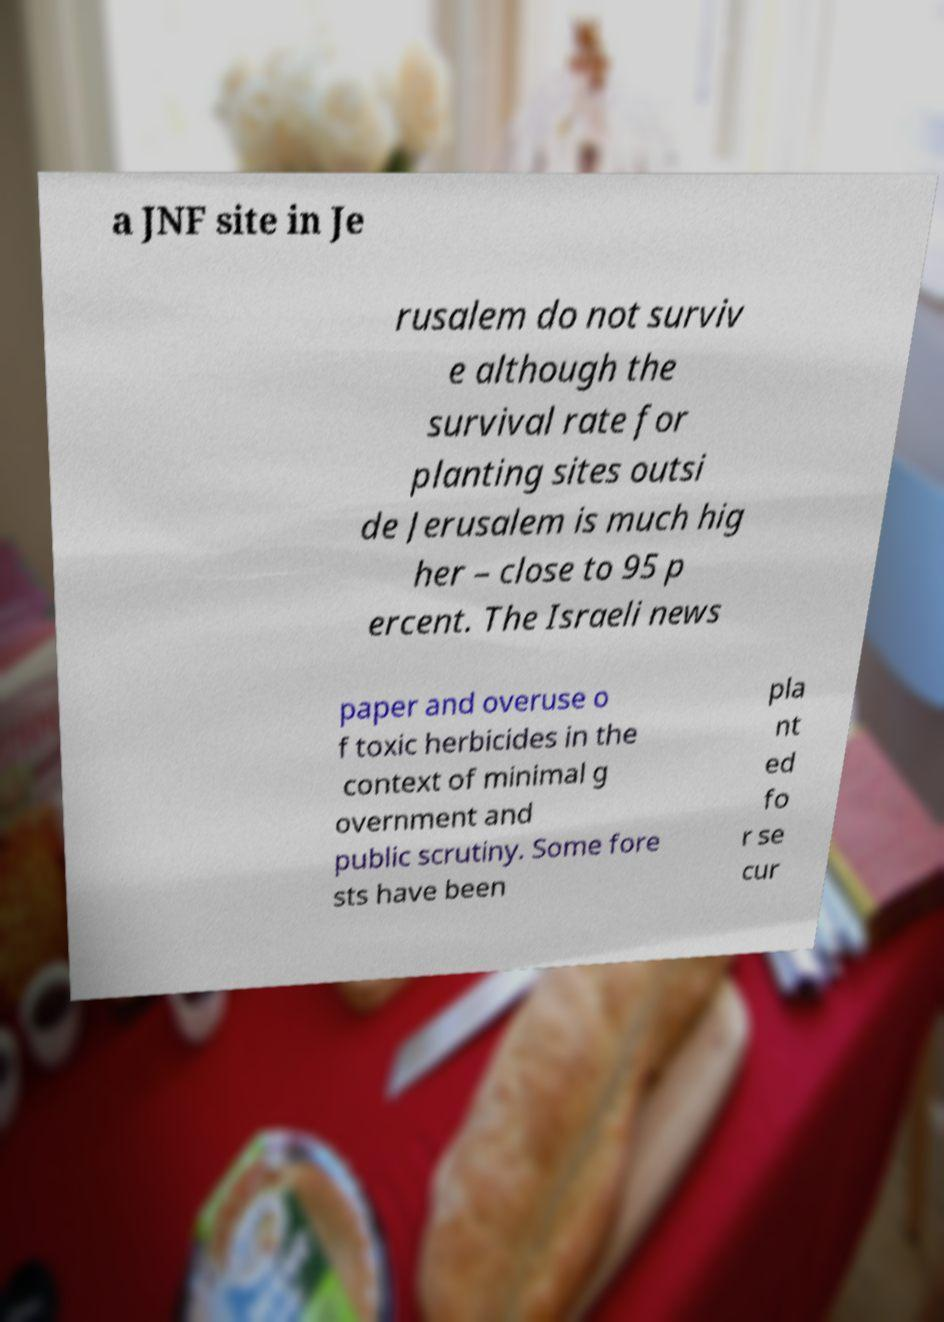There's text embedded in this image that I need extracted. Can you transcribe it verbatim? a JNF site in Je rusalem do not surviv e although the survival rate for planting sites outsi de Jerusalem is much hig her – close to 95 p ercent. The Israeli news paper and overuse o f toxic herbicides in the context of minimal g overnment and public scrutiny. Some fore sts have been pla nt ed fo r se cur 